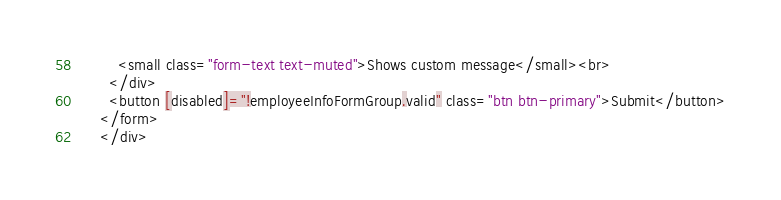Convert code to text. <code><loc_0><loc_0><loc_500><loc_500><_HTML_>        <small class="form-text text-muted">Shows custom message</small><br>
      </div>
      <button [disabled]="!employeeInfoFormGroup.valid" class="btn btn-primary">Submit</button>
    </form>
    </div></code> 